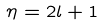<formula> <loc_0><loc_0><loc_500><loc_500>\eta = 2 l + 1</formula> 